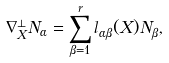Convert formula to latex. <formula><loc_0><loc_0><loc_500><loc_500>\nabla _ { X } ^ { \bot } N _ { \alpha } = \sum _ { \beta = 1 } ^ { r } l _ { \alpha \beta } ( X ) N _ { \beta } ,</formula> 